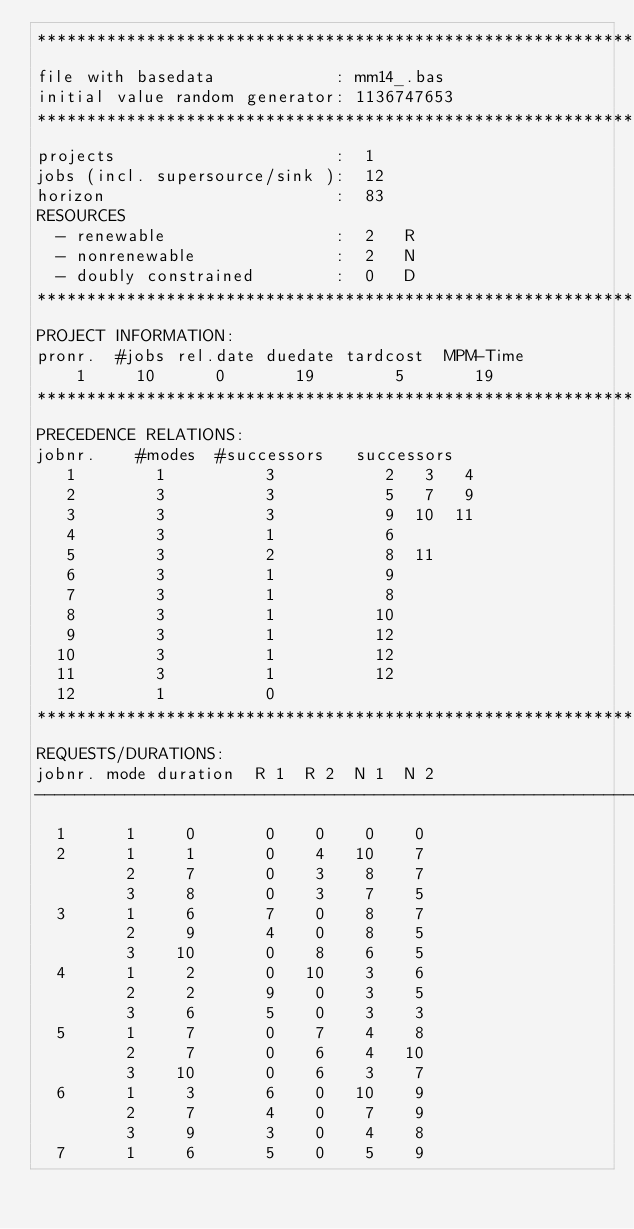<code> <loc_0><loc_0><loc_500><loc_500><_ObjectiveC_>************************************************************************
file with basedata            : mm14_.bas
initial value random generator: 1136747653
************************************************************************
projects                      :  1
jobs (incl. supersource/sink ):  12
horizon                       :  83
RESOURCES
  - renewable                 :  2   R
  - nonrenewable              :  2   N
  - doubly constrained        :  0   D
************************************************************************
PROJECT INFORMATION:
pronr.  #jobs rel.date duedate tardcost  MPM-Time
    1     10      0       19        5       19
************************************************************************
PRECEDENCE RELATIONS:
jobnr.    #modes  #successors   successors
   1        1          3           2   3   4
   2        3          3           5   7   9
   3        3          3           9  10  11
   4        3          1           6
   5        3          2           8  11
   6        3          1           9
   7        3          1           8
   8        3          1          10
   9        3          1          12
  10        3          1          12
  11        3          1          12
  12        1          0        
************************************************************************
REQUESTS/DURATIONS:
jobnr. mode duration  R 1  R 2  N 1  N 2
------------------------------------------------------------------------
  1      1     0       0    0    0    0
  2      1     1       0    4   10    7
         2     7       0    3    8    7
         3     8       0    3    7    5
  3      1     6       7    0    8    7
         2     9       4    0    8    5
         3    10       0    8    6    5
  4      1     2       0   10    3    6
         2     2       9    0    3    5
         3     6       5    0    3    3
  5      1     7       0    7    4    8
         2     7       0    6    4   10
         3    10       0    6    3    7
  6      1     3       6    0   10    9
         2     7       4    0    7    9
         3     9       3    0    4    8
  7      1     6       5    0    5    9</code> 